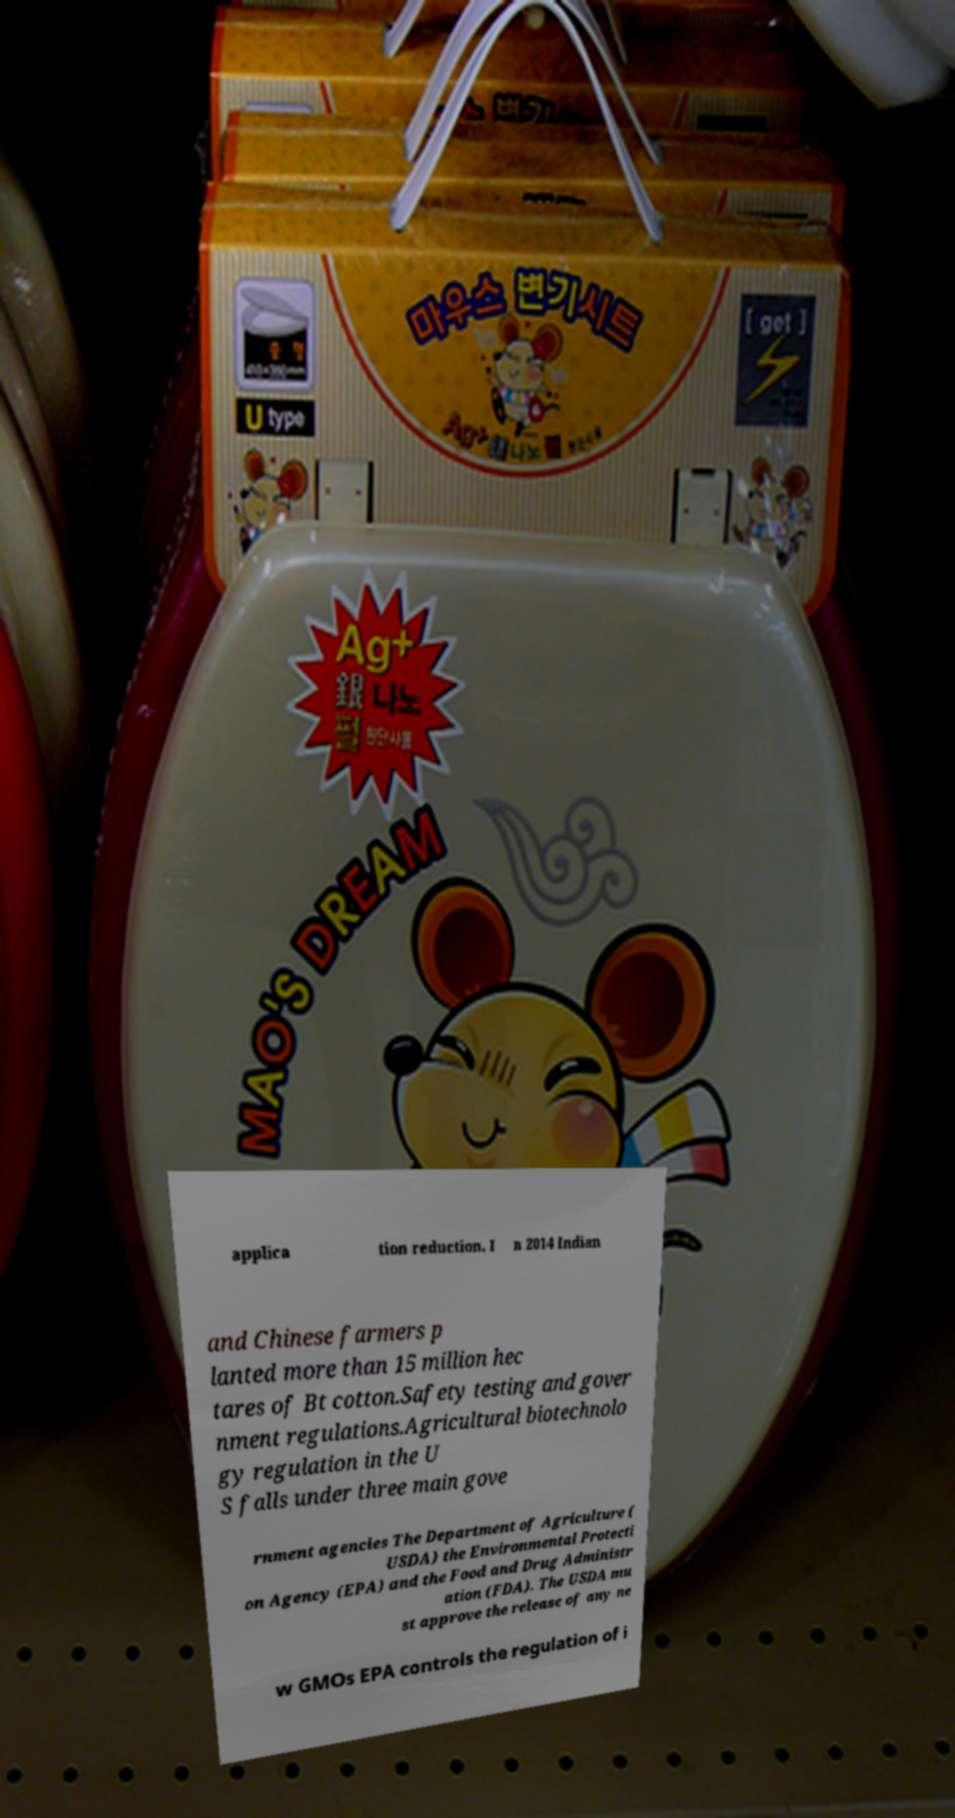I need the written content from this picture converted into text. Can you do that? applica tion reduction. I n 2014 Indian and Chinese farmers p lanted more than 15 million hec tares of Bt cotton.Safety testing and gover nment regulations.Agricultural biotechnolo gy regulation in the U S falls under three main gove rnment agencies The Department of Agriculture ( USDA) the Environmental Protecti on Agency (EPA) and the Food and Drug Administr ation (FDA). The USDA mu st approve the release of any ne w GMOs EPA controls the regulation of i 